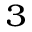Convert formula to latex. <formula><loc_0><loc_0><loc_500><loc_500>_ { 3 }</formula> 